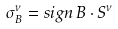Convert formula to latex. <formula><loc_0><loc_0><loc_500><loc_500>\sigma ^ { \nu } _ { B } = s i g n \, B \cdot S ^ { \nu }</formula> 